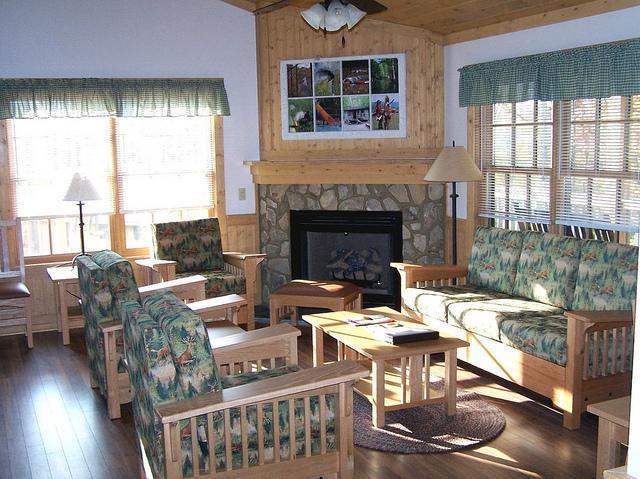How many chairs can you see?
Give a very brief answer. 4. How many people on any type of bike are facing the camera?
Give a very brief answer. 0. 